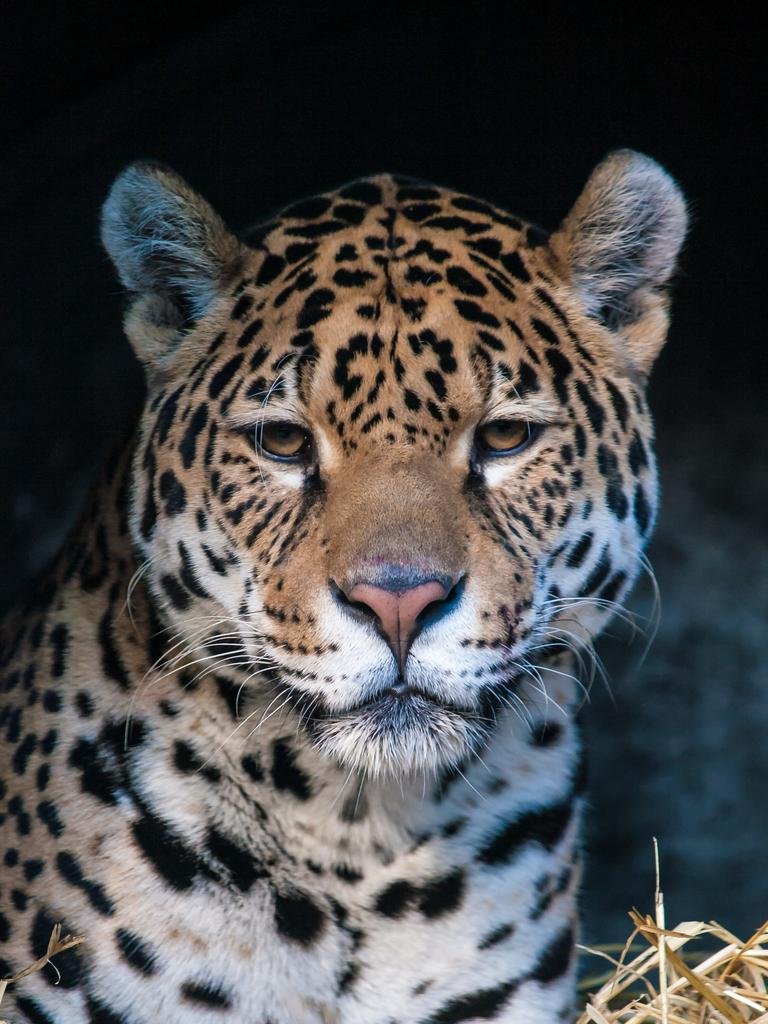What animal is in the image? There is a tiger in the image. What can be observed about the background of the image? The background of the image is dark. What type of corn is being harvested in the image? There is no corn present in the image; it features a tiger with a dark background. 